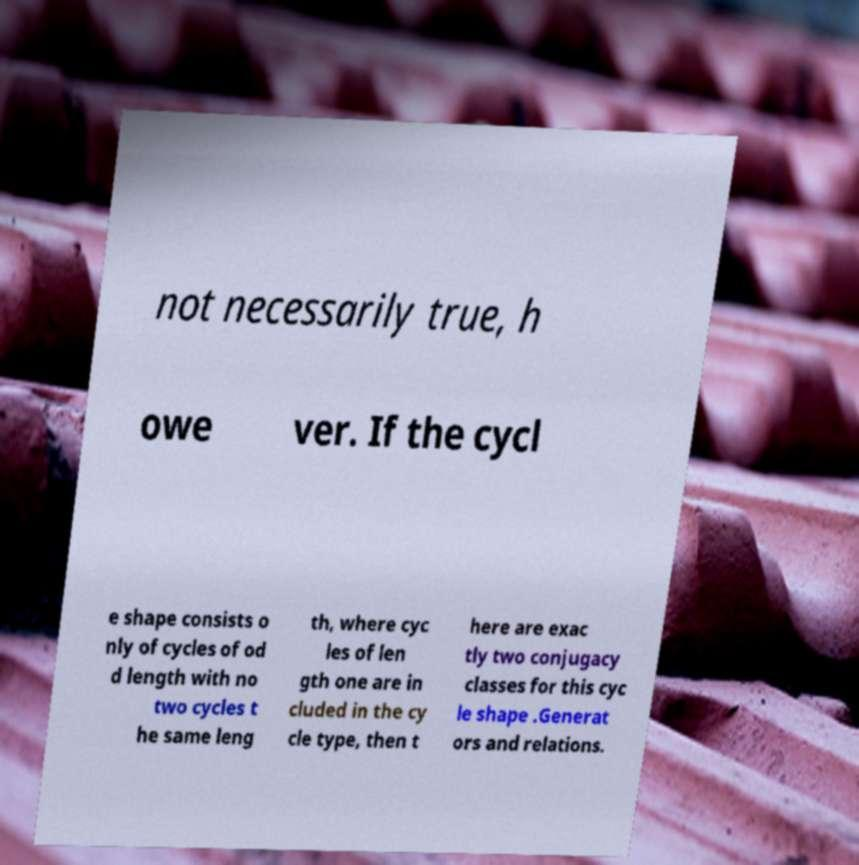Could you extract and type out the text from this image? not necessarily true, h owe ver. If the cycl e shape consists o nly of cycles of od d length with no two cycles t he same leng th, where cyc les of len gth one are in cluded in the cy cle type, then t here are exac tly two conjugacy classes for this cyc le shape .Generat ors and relations. 